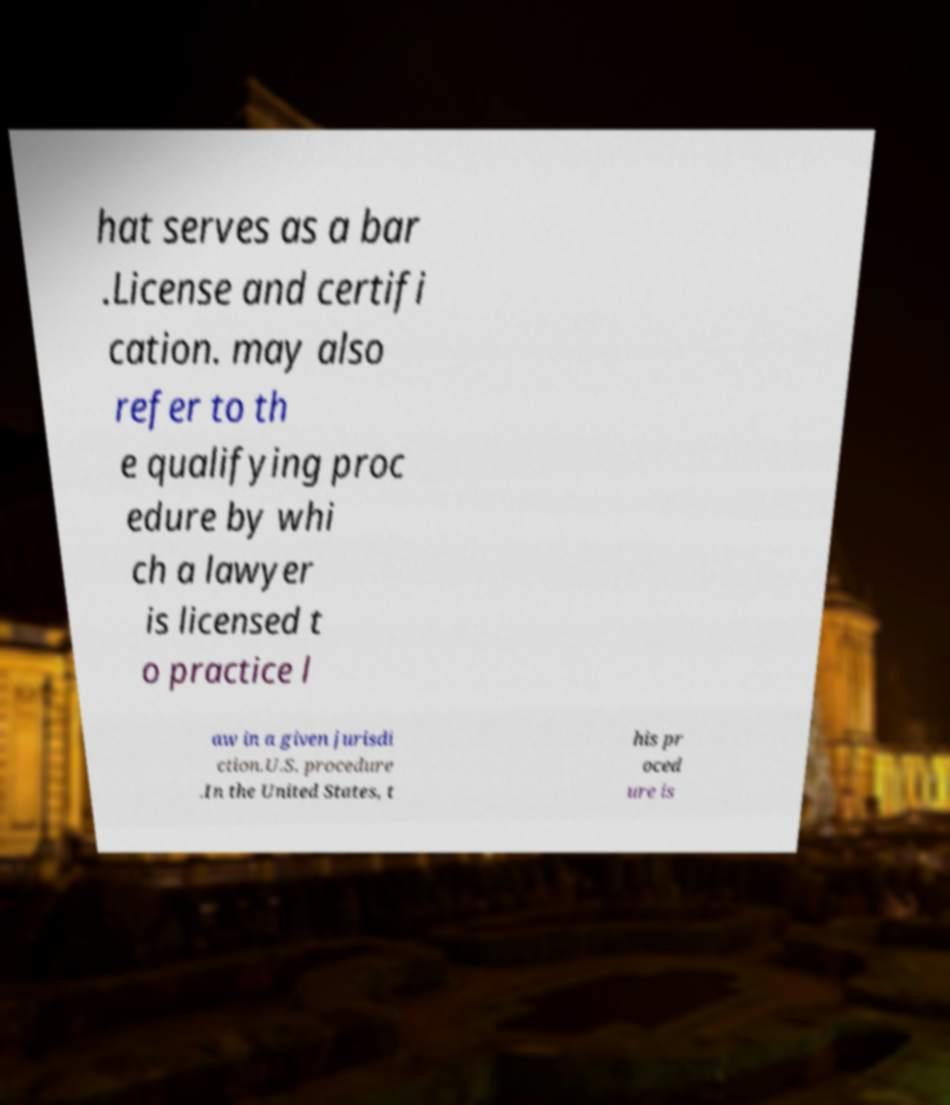There's text embedded in this image that I need extracted. Can you transcribe it verbatim? hat serves as a bar .License and certifi cation. may also refer to th e qualifying proc edure by whi ch a lawyer is licensed t o practice l aw in a given jurisdi ction.U.S. procedure .In the United States, t his pr oced ure is 